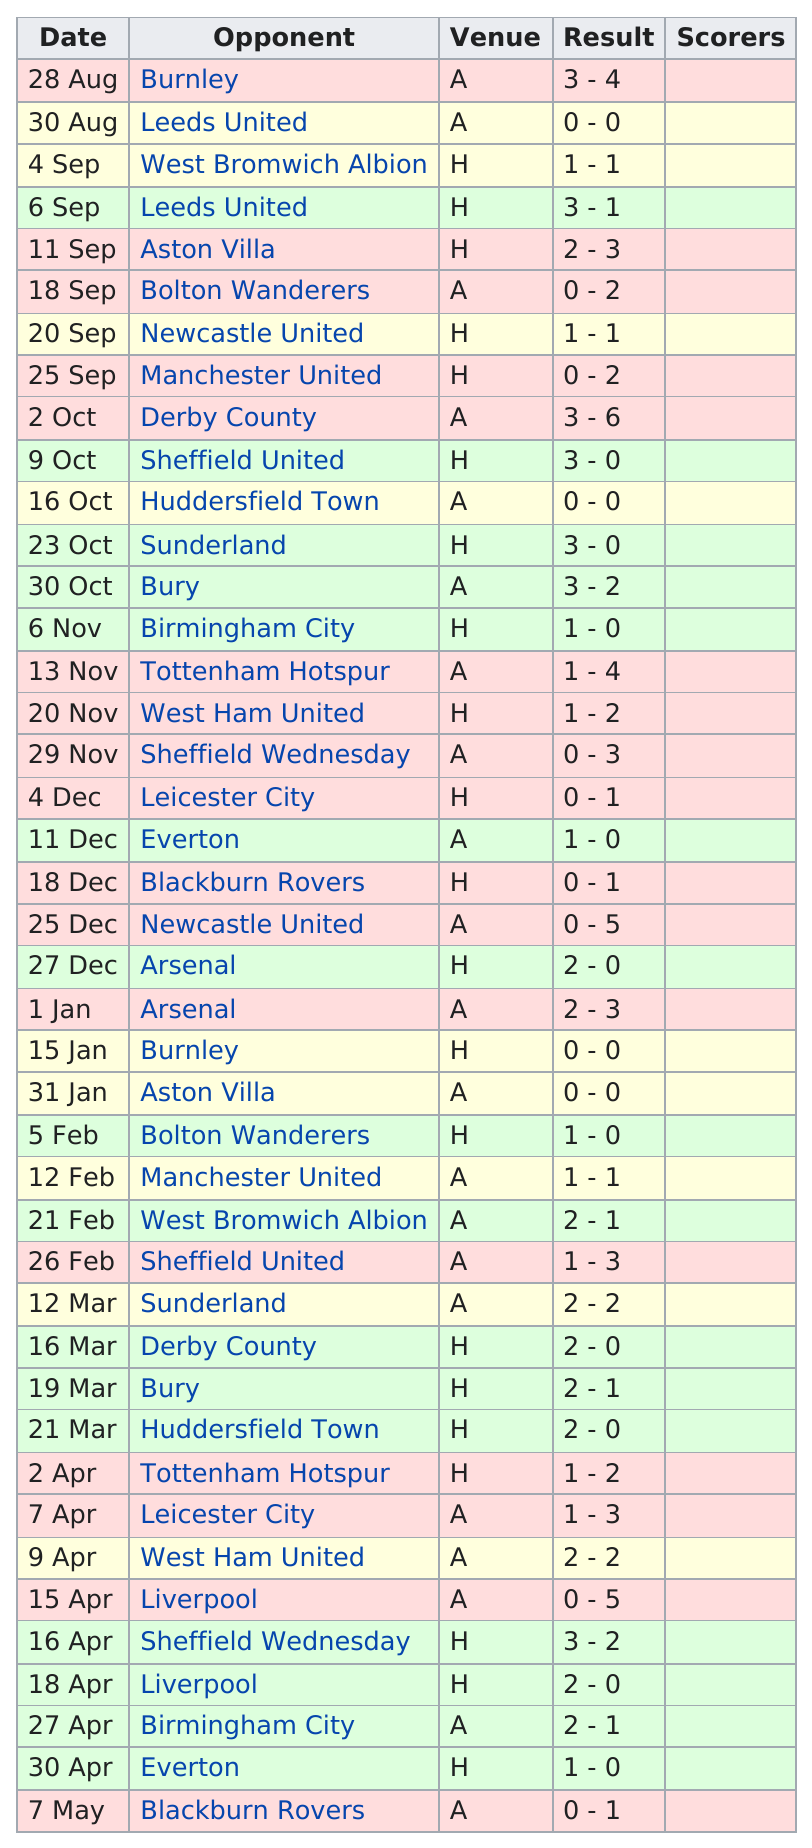Specify some key components in this picture. Cardiff City FC scored at least 3 goals in 7 games. For how long after two consecutive Arsenal games was it? The answer is 5 days. Cardiff City FC scored 12 goals in the month of April. In 12 games, Cardiff City FC failed to score a single goal. Burnley was the opponent who faced the team for the first time in their history. 